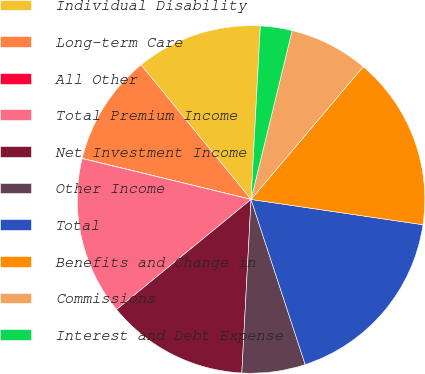Convert chart. <chart><loc_0><loc_0><loc_500><loc_500><pie_chart><fcel>Individual Disability<fcel>Long-term Care<fcel>All Other<fcel>Total Premium Income<fcel>Net Investment Income<fcel>Other Income<fcel>Total<fcel>Benefits and Change in<fcel>Commissions<fcel>Interest and Debt Expense<nl><fcel>11.76%<fcel>10.29%<fcel>0.02%<fcel>14.7%<fcel>13.23%<fcel>5.89%<fcel>17.63%<fcel>16.16%<fcel>7.36%<fcel>2.95%<nl></chart> 